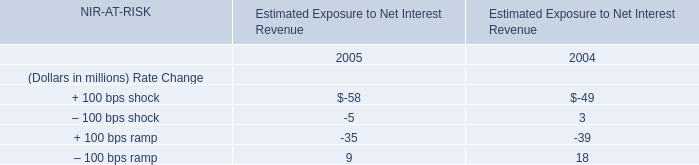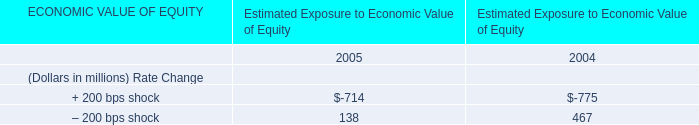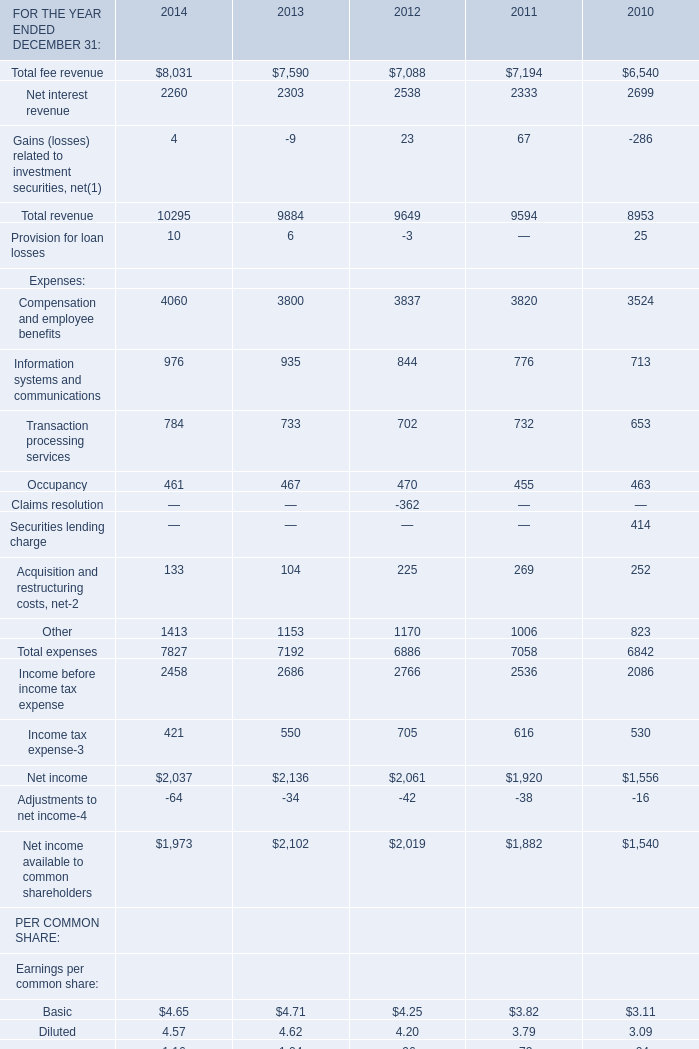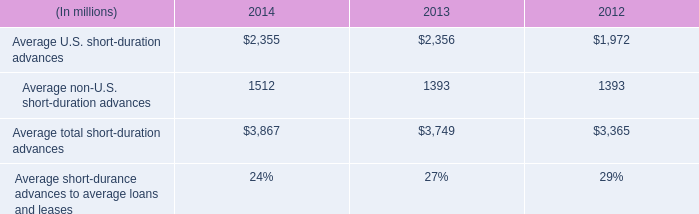what is the percent change in average u.s . short-duration advances between 2012 and 2013? 
Computations: ((2356 - 1972) / 1972)
Answer: 0.19473. 